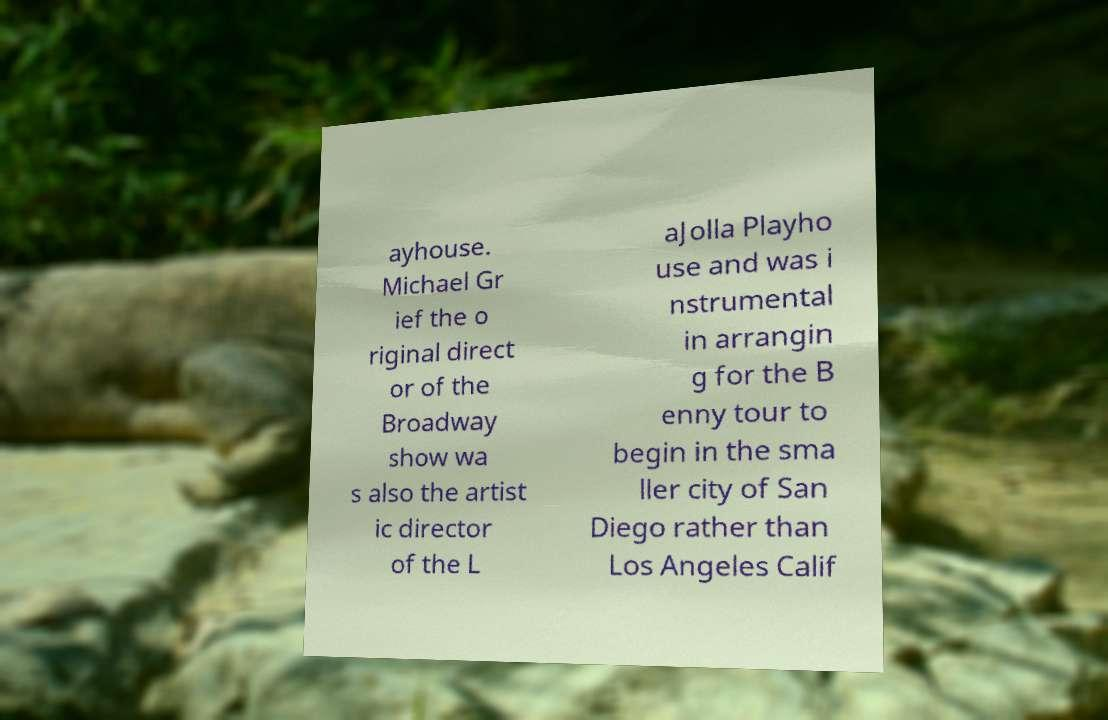What messages or text are displayed in this image? I need them in a readable, typed format. ayhouse. Michael Gr ief the o riginal direct or of the Broadway show wa s also the artist ic director of the L aJolla Playho use and was i nstrumental in arrangin g for the B enny tour to begin in the sma ller city of San Diego rather than Los Angeles Calif 